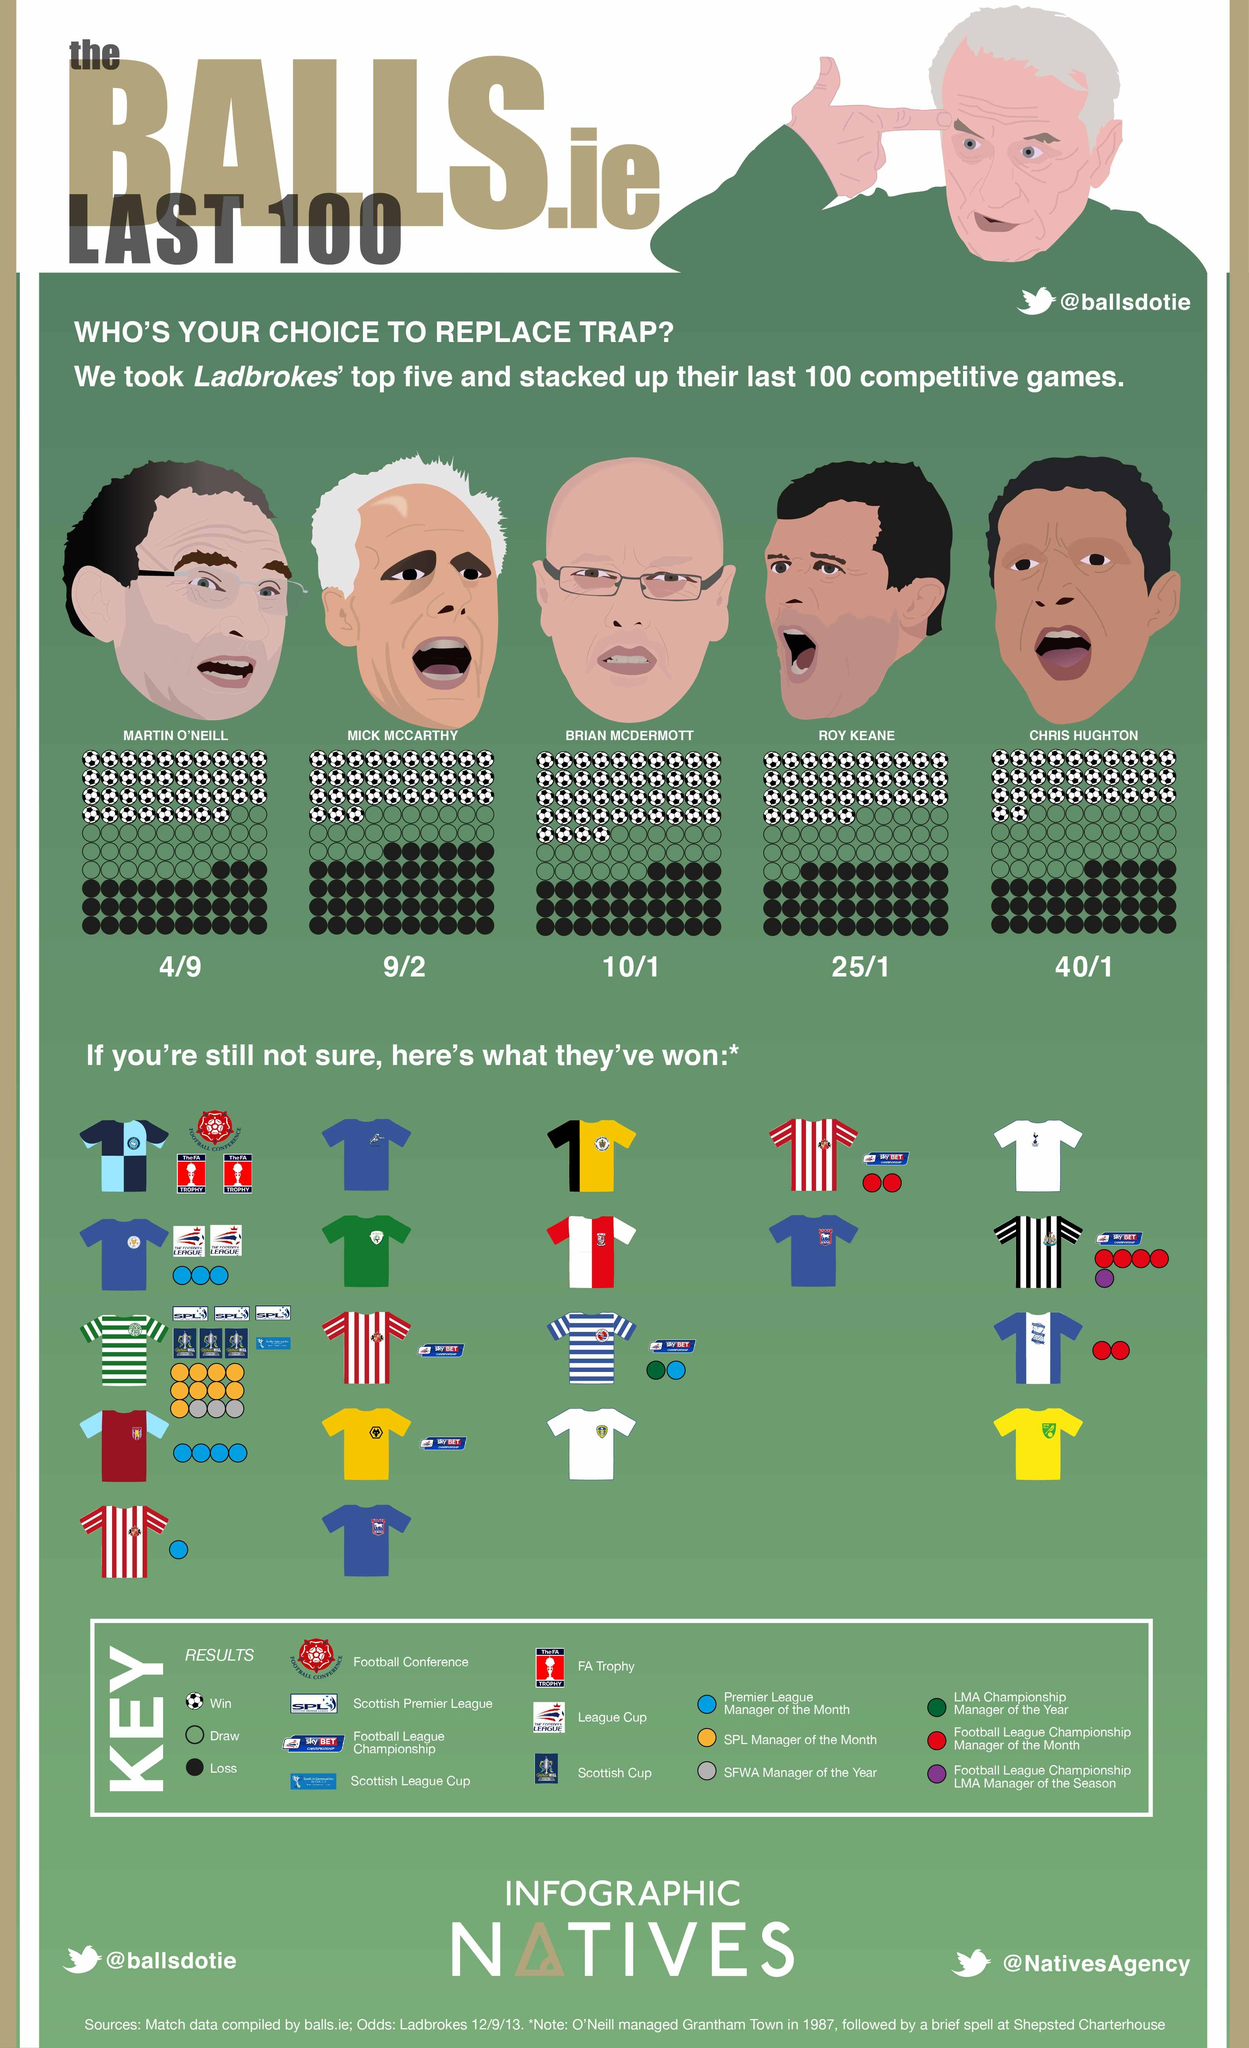Identify some key points in this picture. The yellow colored circle in the KEY denotes that the SPL Manager of the Month has been achieved. Out of the men shown, two have white or grey hair. There are 35 soccer balls visible under the direction of Roy Keane. Of the jerseys displayed, three of them have a yellow color. In the image, there are two horizontally striped jerseys displayed. 